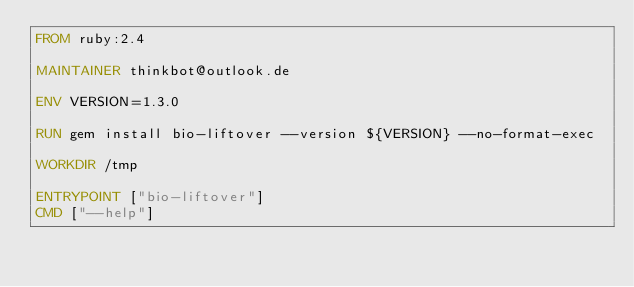Convert code to text. <code><loc_0><loc_0><loc_500><loc_500><_Dockerfile_>FROM ruby:2.4

MAINTAINER thinkbot@outlook.de

ENV VERSION=1.3.0

RUN gem install bio-liftover --version ${VERSION} --no-format-exec

WORKDIR /tmp

ENTRYPOINT ["bio-liftover"]
CMD ["--help"]
</code> 